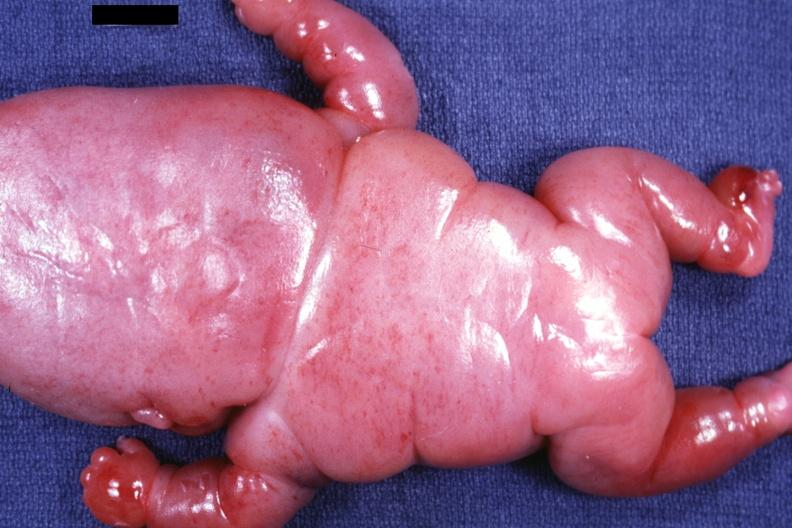s lymphangiomatosis present?
Answer the question using a single word or phrase. Yes 